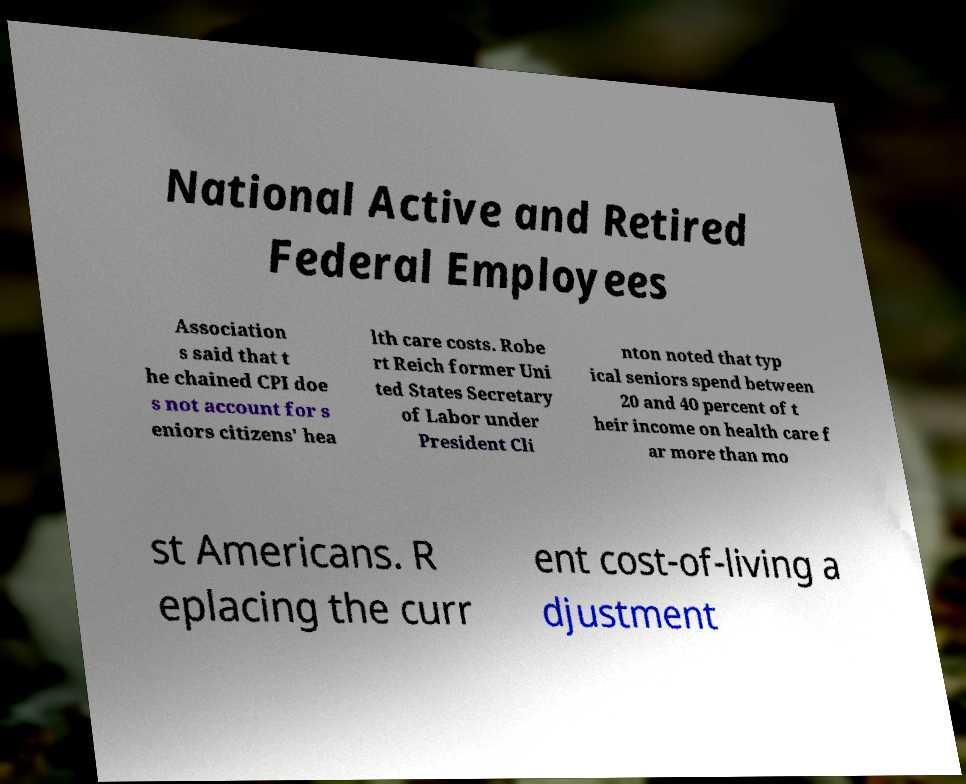Please identify and transcribe the text found in this image. National Active and Retired Federal Employees Association s said that t he chained CPI doe s not account for s eniors citizens' hea lth care costs. Robe rt Reich former Uni ted States Secretary of Labor under President Cli nton noted that typ ical seniors spend between 20 and 40 percent of t heir income on health care f ar more than mo st Americans. R eplacing the curr ent cost-of-living a djustment 